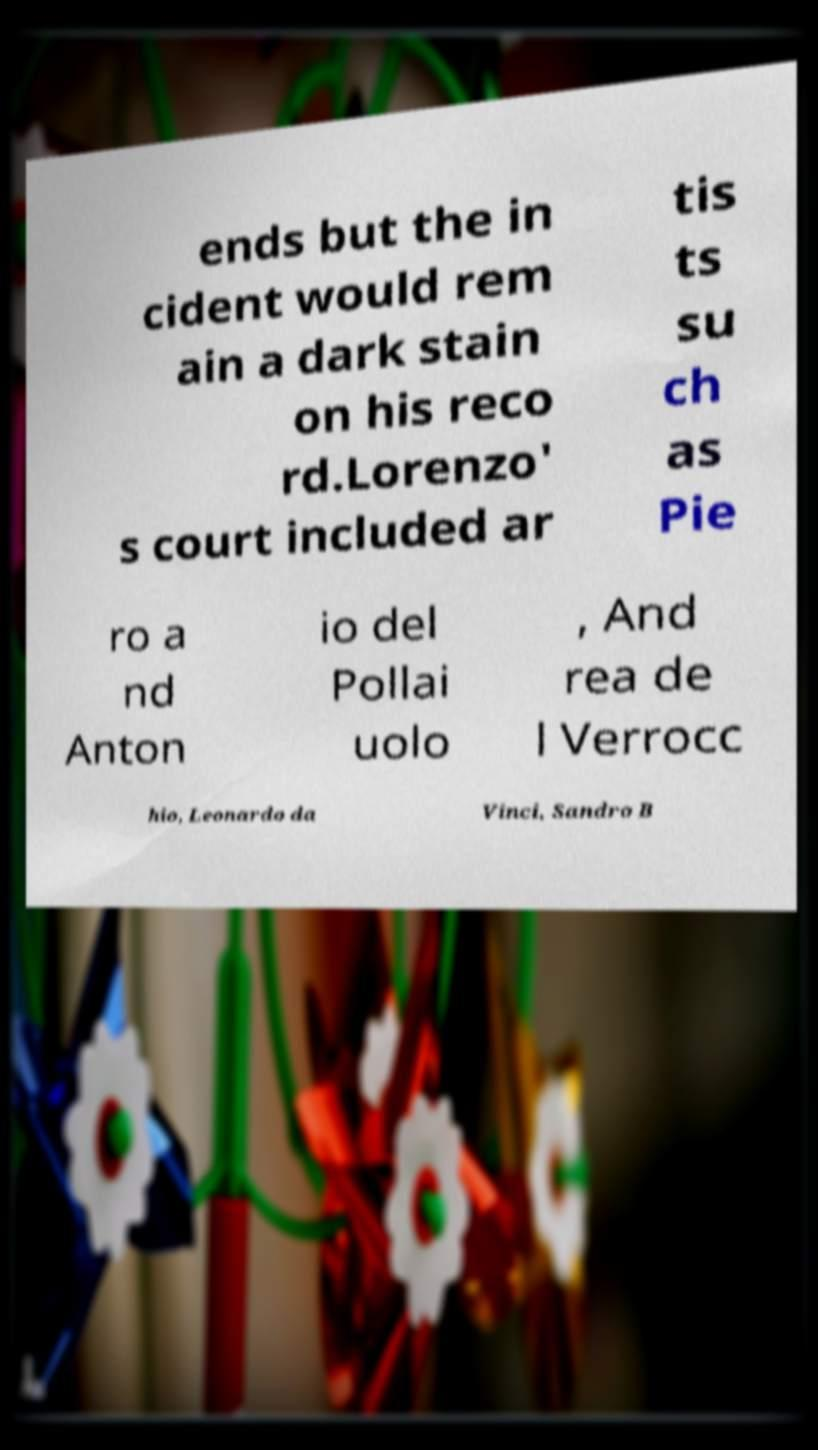Please read and relay the text visible in this image. What does it say? ends but the in cident would rem ain a dark stain on his reco rd.Lorenzo' s court included ar tis ts su ch as Pie ro a nd Anton io del Pollai uolo , And rea de l Verrocc hio, Leonardo da Vinci, Sandro B 